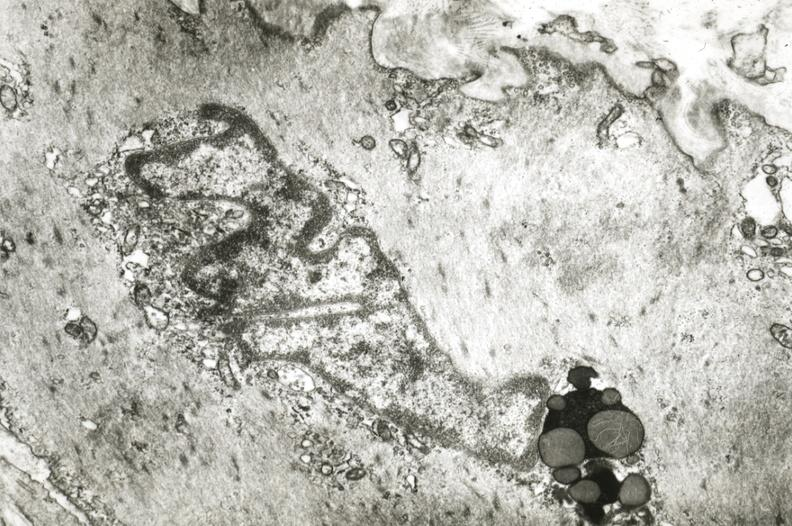s infant body present?
Answer the question using a single word or phrase. No 